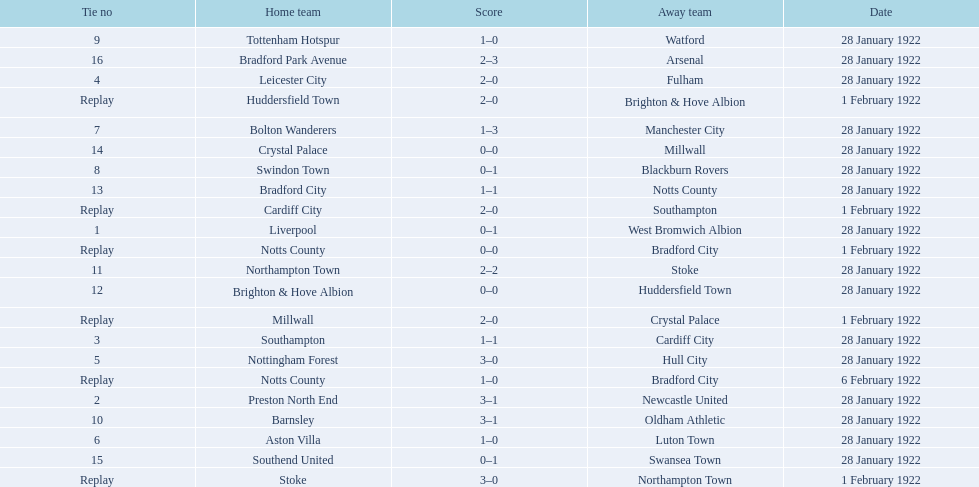What home team had the same score as aston villa on january 28th, 1922? Tottenham Hotspur. 